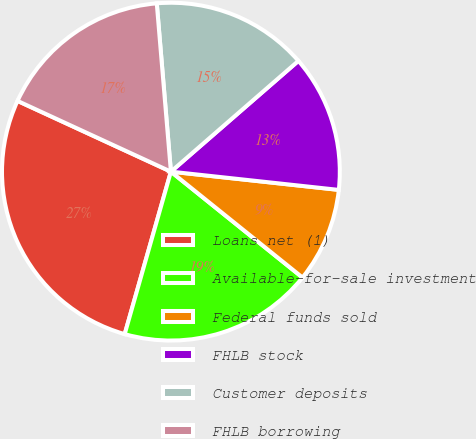Convert chart to OTSL. <chart><loc_0><loc_0><loc_500><loc_500><pie_chart><fcel>Loans net (1)<fcel>Available-for-sale investment<fcel>Federal funds sold<fcel>FHLB stock<fcel>Customer deposits<fcel>FHLB borrowing<nl><fcel>27.47%<fcel>18.63%<fcel>9.06%<fcel>13.11%<fcel>14.95%<fcel>16.79%<nl></chart> 